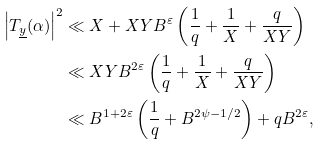Convert formula to latex. <formula><loc_0><loc_0><loc_500><loc_500>\left | T _ { \underline { y } } ( \alpha ) \right | ^ { 2 } & \ll X + X Y B ^ { \varepsilon } \left ( \frac { 1 } { q } + \frac { 1 } { X } + \frac { q } { X Y } \right ) \\ & \ll X Y B ^ { 2 \varepsilon } \left ( \frac { 1 } { q } + \frac { 1 } { X } + \frac { q } { X Y } \right ) \\ & \ll B ^ { 1 + 2 \varepsilon } \left ( \frac { 1 } { q } + B ^ { 2 \psi - 1 / 2 } \right ) + q B ^ { 2 \varepsilon } ,</formula> 